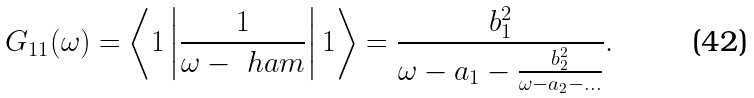<formula> <loc_0><loc_0><loc_500><loc_500>G _ { 1 1 } ( \omega ) = \left \langle 1 \left | \frac { 1 } { \omega - \ h a m } \right | 1 \right \rangle = \frac { b _ { 1 } ^ { 2 } } { \omega - a _ { 1 } - \frac { b _ { 2 } ^ { 2 } } { \omega - a _ { 2 } - \dots } } .</formula> 